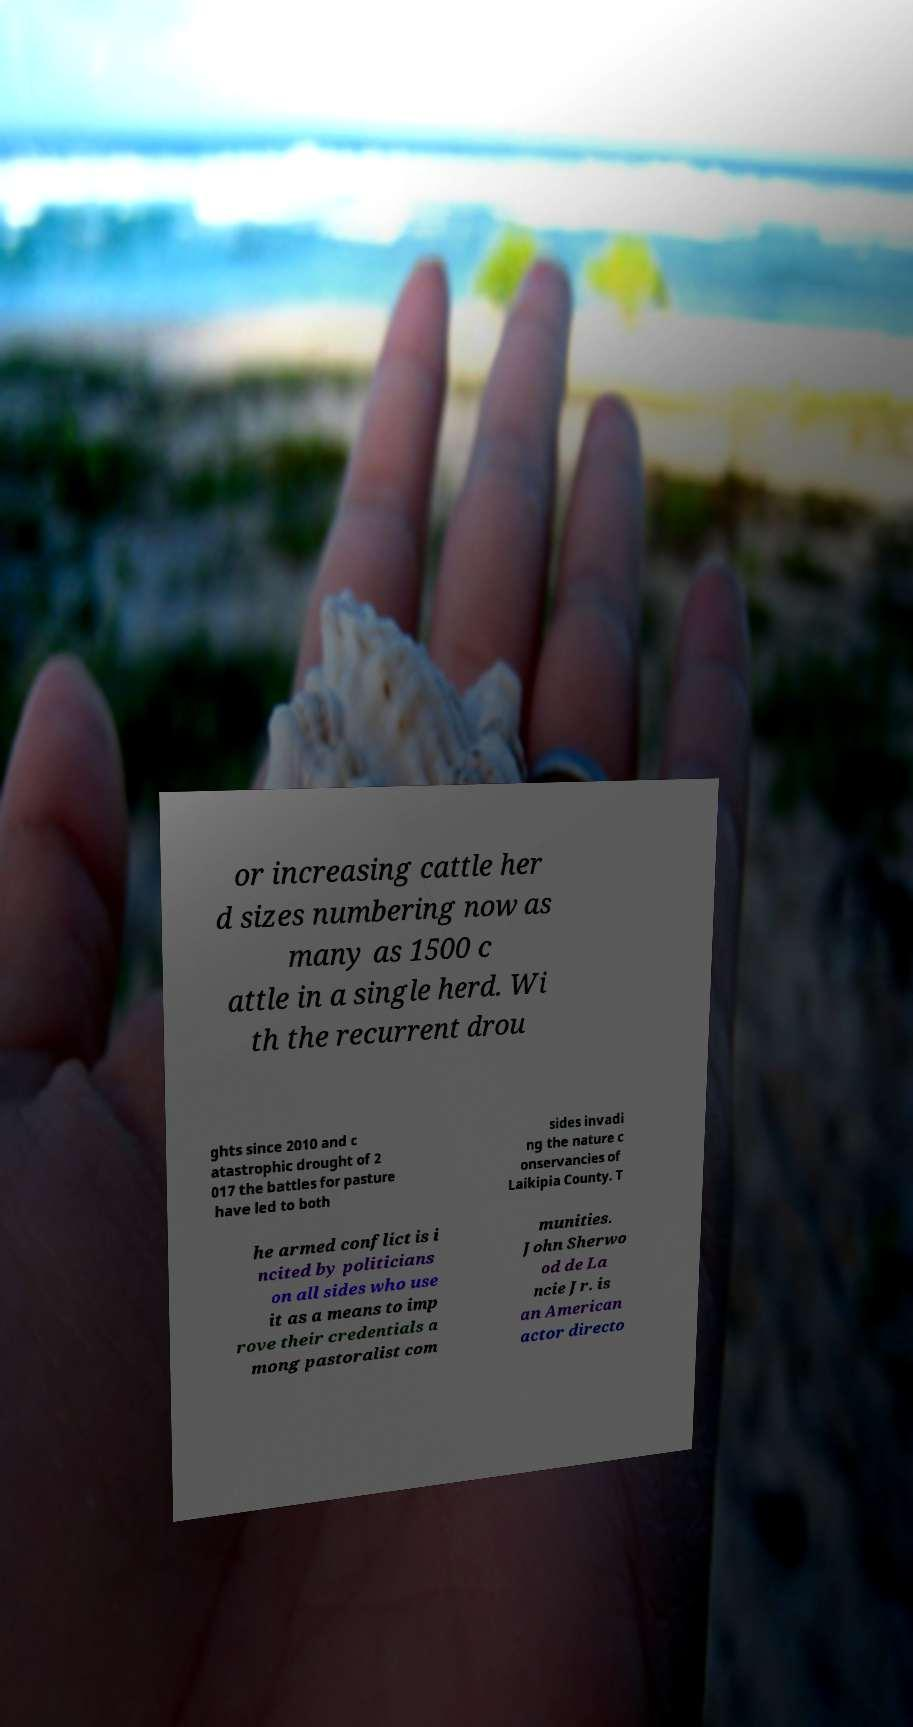Can you accurately transcribe the text from the provided image for me? or increasing cattle her d sizes numbering now as many as 1500 c attle in a single herd. Wi th the recurrent drou ghts since 2010 and c atastrophic drought of 2 017 the battles for pasture have led to both sides invadi ng the nature c onservancies of Laikipia County. T he armed conflict is i ncited by politicians on all sides who use it as a means to imp rove their credentials a mong pastoralist com munities. John Sherwo od de La ncie Jr. is an American actor directo 